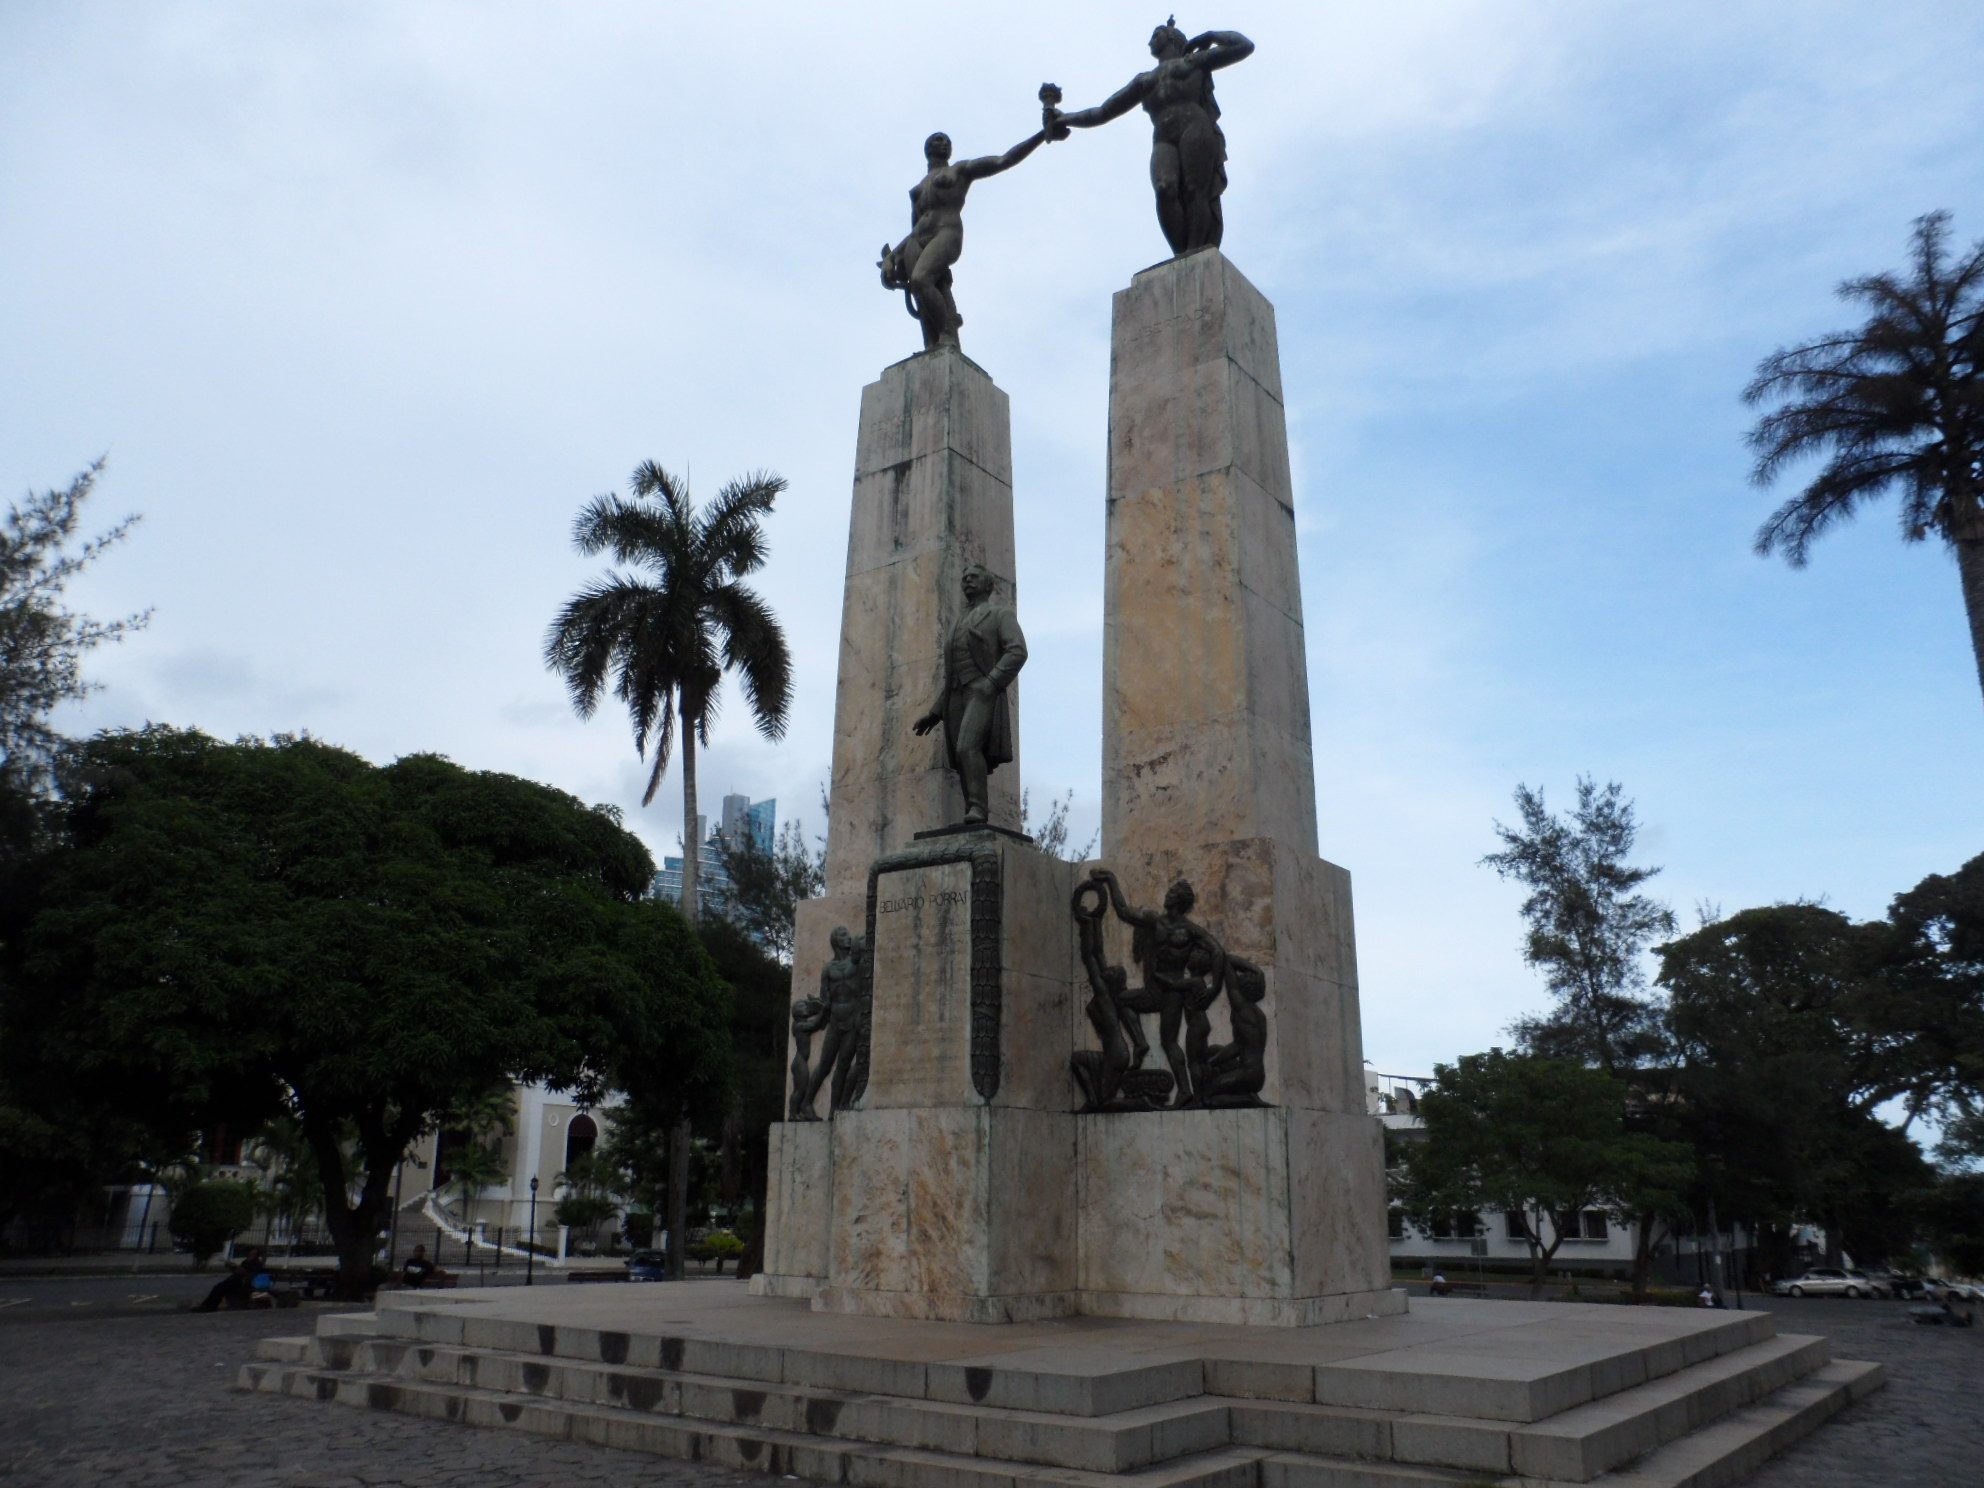In one or two sentences, can you explain what this image depicts? In this image there are statues, in the background there are trees, buildings and sky. 